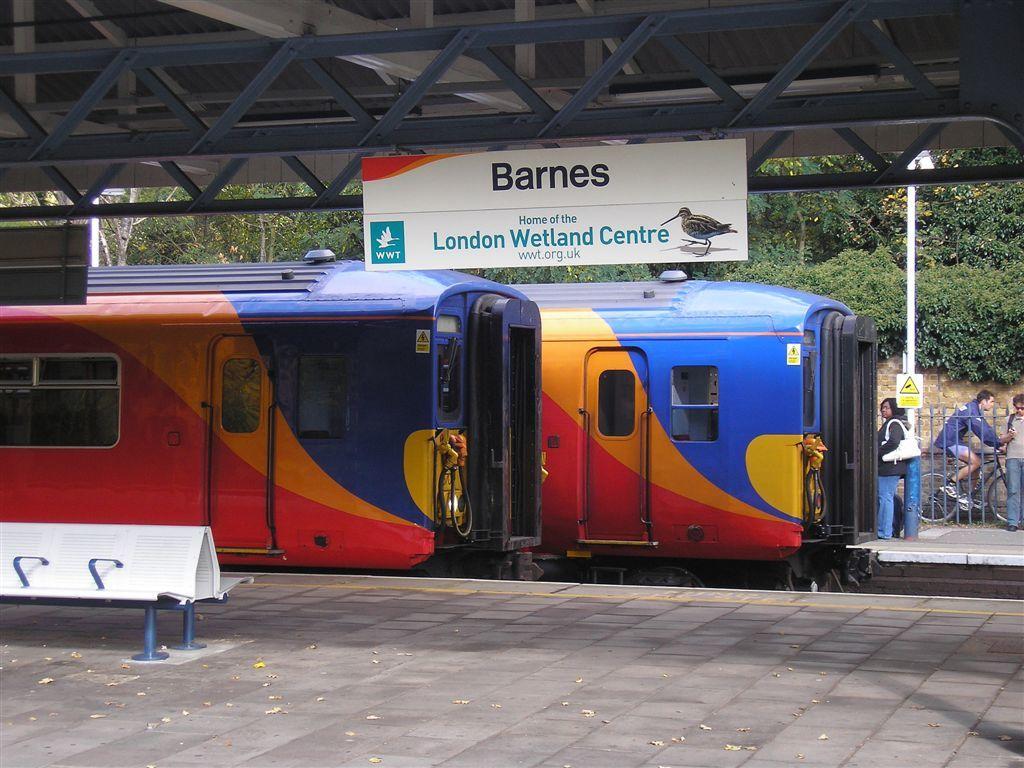What is barnes home of?
Your answer should be compact. London wetland centre. What is this place the home of?
Your response must be concise. London wetland centre. 